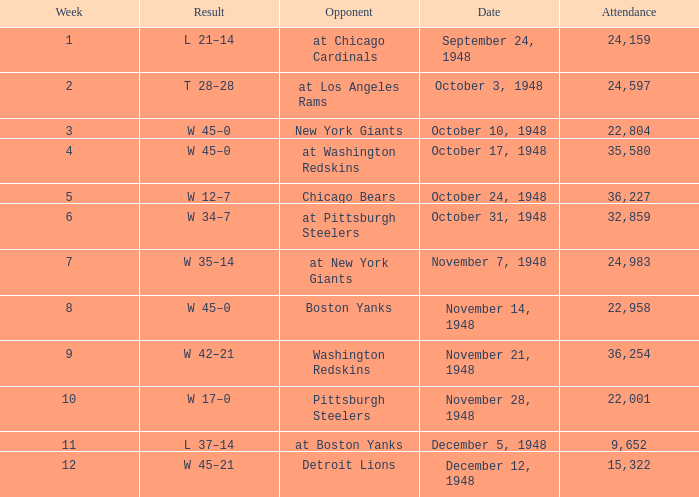Can you give me this table as a dict? {'header': ['Week', 'Result', 'Opponent', 'Date', 'Attendance'], 'rows': [['1', 'L 21–14', 'at Chicago Cardinals', 'September 24, 1948', '24,159'], ['2', 'T 28–28', 'at Los Angeles Rams', 'October 3, 1948', '24,597'], ['3', 'W 45–0', 'New York Giants', 'October 10, 1948', '22,804'], ['4', 'W 45–0', 'at Washington Redskins', 'October 17, 1948', '35,580'], ['5', 'W 12–7', 'Chicago Bears', 'October 24, 1948', '36,227'], ['6', 'W 34–7', 'at Pittsburgh Steelers', 'October 31, 1948', '32,859'], ['7', 'W 35–14', 'at New York Giants', 'November 7, 1948', '24,983'], ['8', 'W 45–0', 'Boston Yanks', 'November 14, 1948', '22,958'], ['9', 'W 42–21', 'Washington Redskins', 'November 21, 1948', '36,254'], ['10', 'W 17–0', 'Pittsburgh Steelers', 'November 28, 1948', '22,001'], ['11', 'L 37–14', 'at Boston Yanks', 'December 5, 1948', '9,652'], ['12', 'W 45–21', 'Detroit Lions', 'December 12, 1948', '15,322']]} What is the lowest value for Week, when the Attendance is greater than 22,958, and when the Opponent is At Chicago Cardinals? 1.0. 